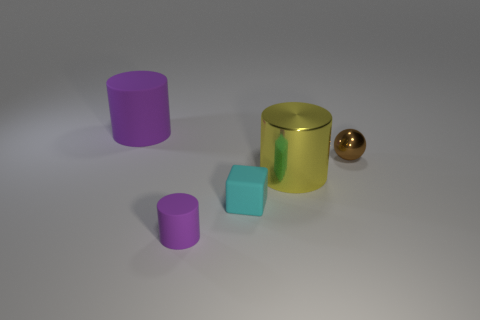Do the rubber thing that is right of the tiny purple matte object and the big object that is behind the big yellow shiny thing have the same color?
Your answer should be compact. No. There is another purple matte object that is the same shape as the small purple thing; what is its size?
Offer a very short reply. Large. Are the large cylinder that is behind the big metal cylinder and the cylinder right of the small purple thing made of the same material?
Your answer should be compact. No. What number of matte objects are either blue objects or large cylinders?
Offer a terse response. 1. There is a purple object that is in front of the object that is behind the tiny object on the right side of the small cyan matte object; what is its material?
Your answer should be very brief. Rubber. Is the shape of the big object to the right of the big purple matte cylinder the same as the small matte thing that is in front of the tiny cyan object?
Offer a terse response. Yes. What color is the matte thing that is to the left of the rubber cylinder that is right of the large purple rubber object?
Your answer should be compact. Purple. How many cubes are either tiny things or large purple matte objects?
Provide a succinct answer. 1. How many tiny purple objects are on the left side of the purple object that is right of the purple object behind the brown metal sphere?
Give a very brief answer. 0. What is the size of the other rubber thing that is the same color as the big rubber object?
Your answer should be compact. Small. 